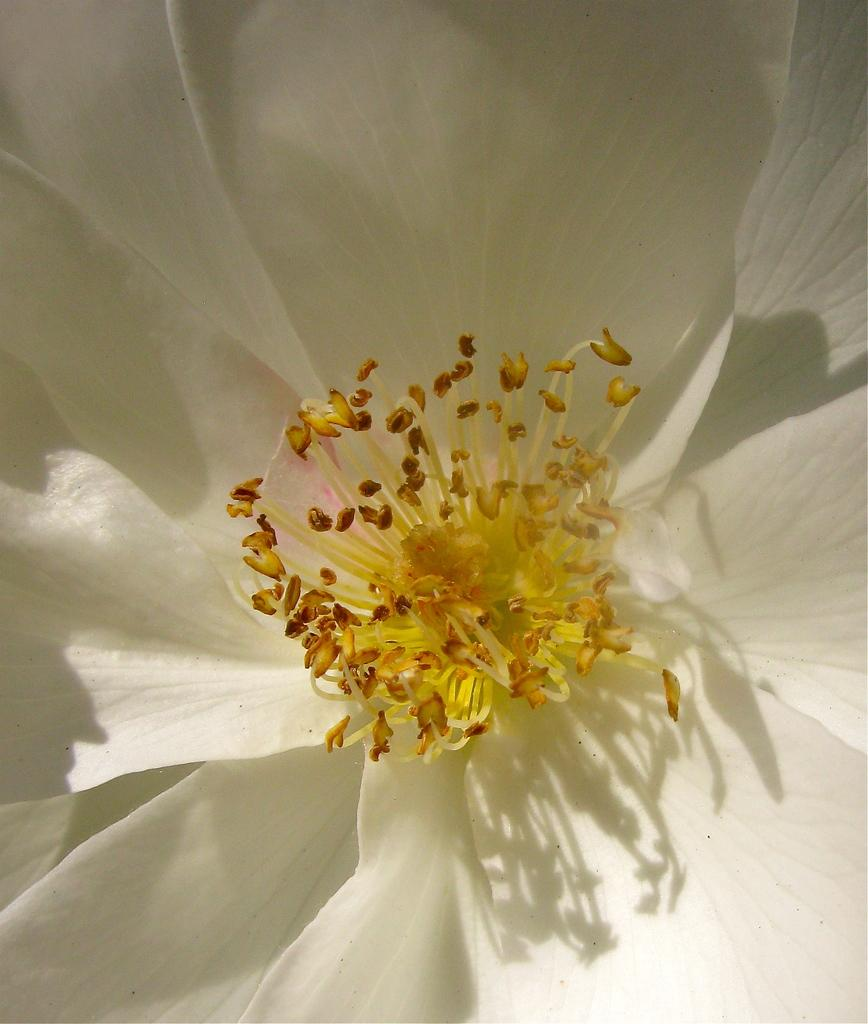What type of flower is present in the image? There is a white color flower in the image. Is the person in the image reading a book while riding a bike? There is no person present in the image, and therefore no such activity can be observed. 